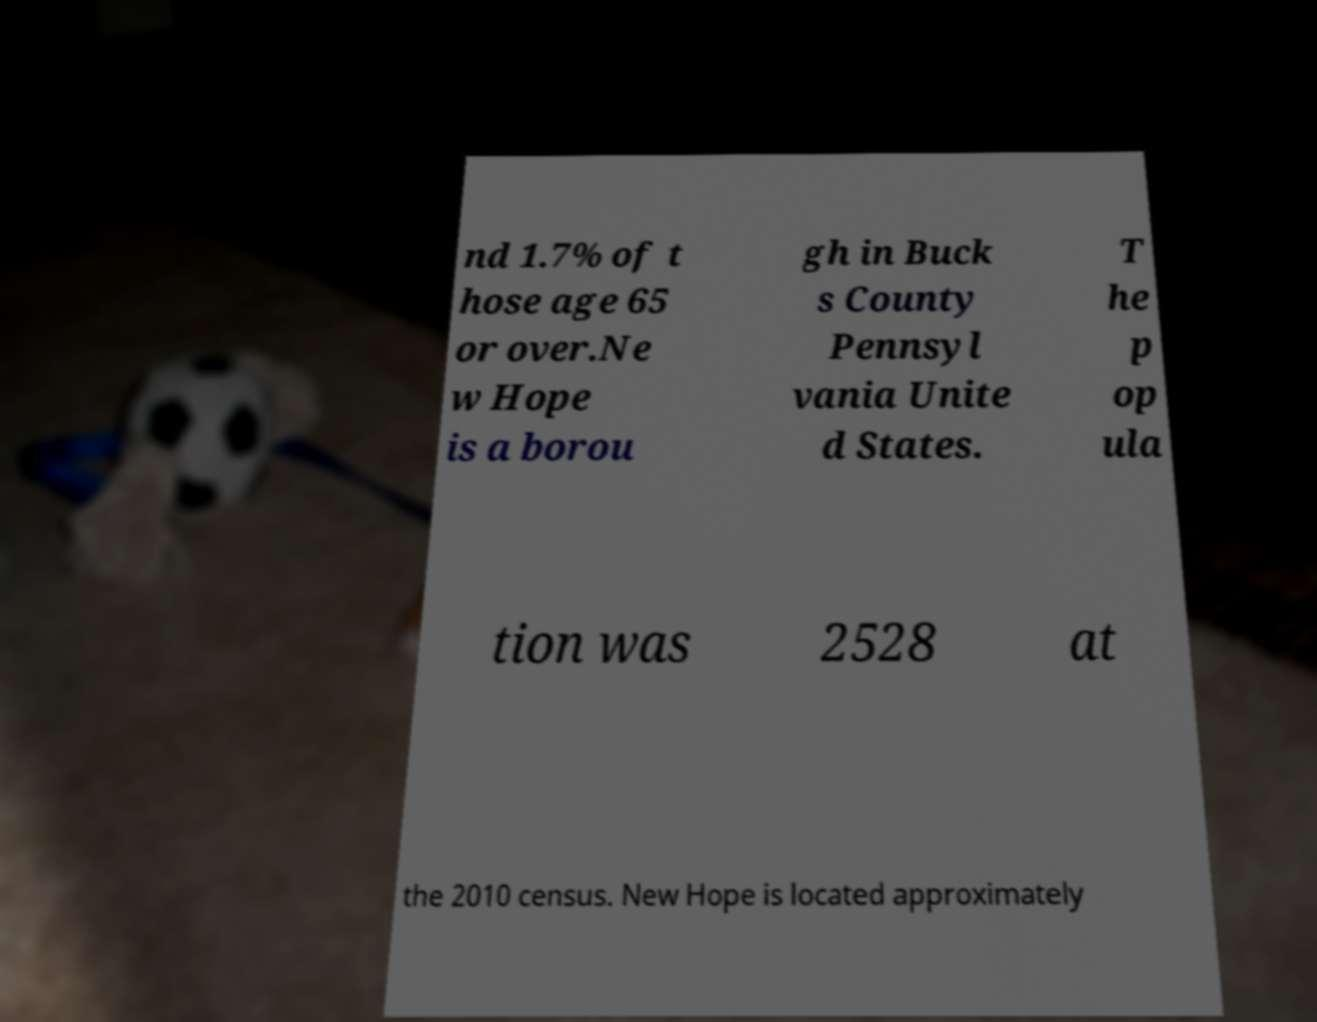Can you read and provide the text displayed in the image?This photo seems to have some interesting text. Can you extract and type it out for me? nd 1.7% of t hose age 65 or over.Ne w Hope is a borou gh in Buck s County Pennsyl vania Unite d States. T he p op ula tion was 2528 at the 2010 census. New Hope is located approximately 